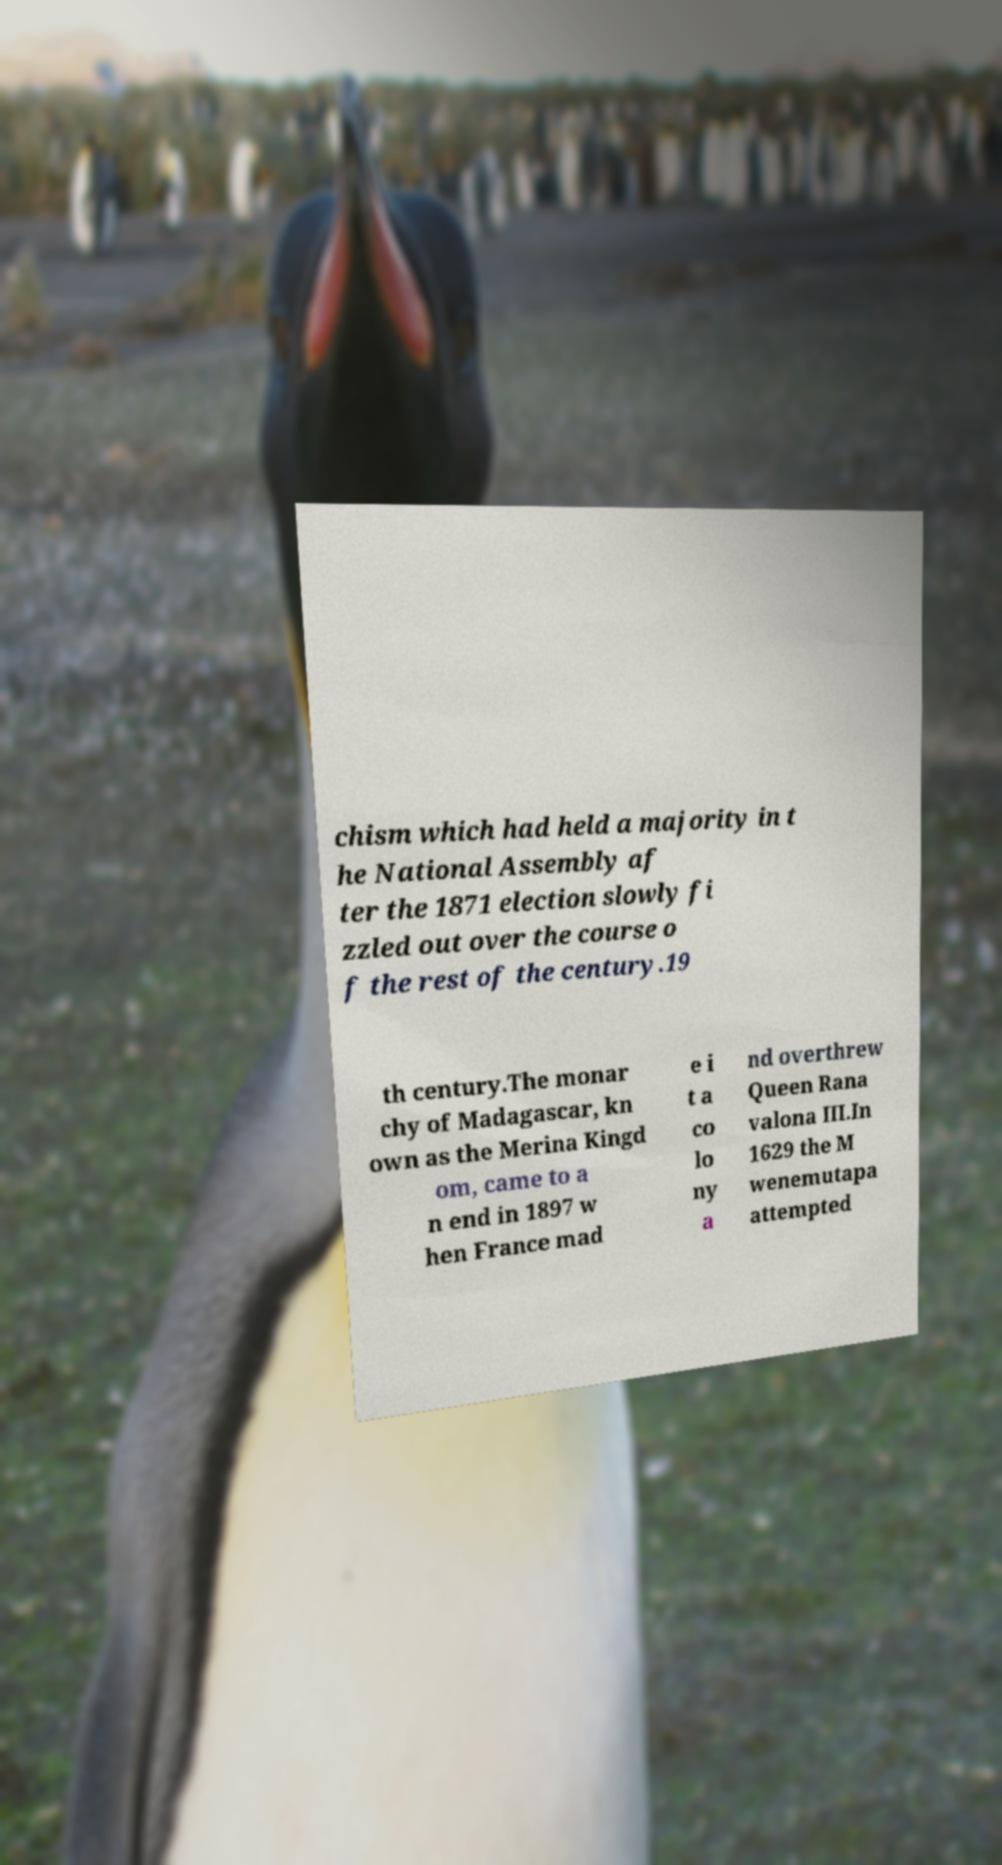Can you accurately transcribe the text from the provided image for me? chism which had held a majority in t he National Assembly af ter the 1871 election slowly fi zzled out over the course o f the rest of the century.19 th century.The monar chy of Madagascar, kn own as the Merina Kingd om, came to a n end in 1897 w hen France mad e i t a co lo ny a nd overthrew Queen Rana valona III.In 1629 the M wenemutapa attempted 